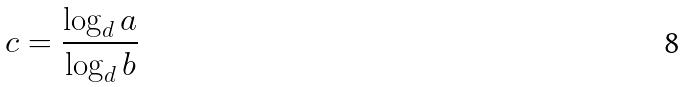Convert formula to latex. <formula><loc_0><loc_0><loc_500><loc_500>c = \frac { \log _ { d } a } { \log _ { d } b }</formula> 